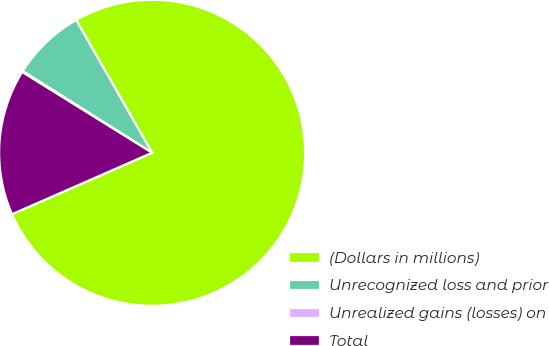<chart> <loc_0><loc_0><loc_500><loc_500><pie_chart><fcel>(Dollars in millions)<fcel>Unrecognized loss and prior<fcel>Unrealized gains (losses) on<fcel>Total<nl><fcel>76.69%<fcel>7.77%<fcel>0.11%<fcel>15.43%<nl></chart> 